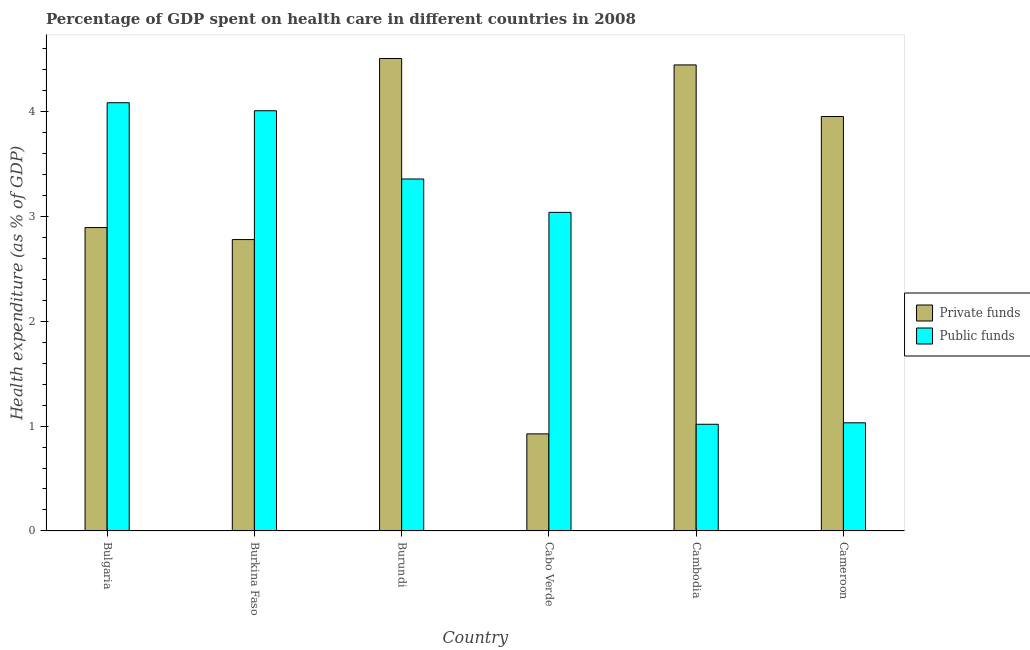Are the number of bars per tick equal to the number of legend labels?
Provide a short and direct response. Yes. How many bars are there on the 5th tick from the right?
Provide a short and direct response. 2. What is the label of the 5th group of bars from the left?
Your answer should be very brief. Cambodia. In how many cases, is the number of bars for a given country not equal to the number of legend labels?
Offer a terse response. 0. What is the amount of private funds spent in healthcare in Bulgaria?
Provide a short and direct response. 2.89. Across all countries, what is the maximum amount of public funds spent in healthcare?
Your answer should be very brief. 4.08. Across all countries, what is the minimum amount of private funds spent in healthcare?
Your answer should be compact. 0.93. In which country was the amount of private funds spent in healthcare minimum?
Your response must be concise. Cabo Verde. What is the total amount of public funds spent in healthcare in the graph?
Your answer should be very brief. 16.53. What is the difference between the amount of public funds spent in healthcare in Cabo Verde and that in Cameroon?
Keep it short and to the point. 2.01. What is the difference between the amount of public funds spent in healthcare in Cambodia and the amount of private funds spent in healthcare in Burkina Faso?
Your response must be concise. -1.76. What is the average amount of private funds spent in healthcare per country?
Offer a terse response. 3.25. What is the difference between the amount of public funds spent in healthcare and amount of private funds spent in healthcare in Cameroon?
Your response must be concise. -2.92. In how many countries, is the amount of private funds spent in healthcare greater than 4.4 %?
Give a very brief answer. 2. What is the ratio of the amount of public funds spent in healthcare in Burundi to that in Cameroon?
Your answer should be compact. 3.25. Is the difference between the amount of private funds spent in healthcare in Cabo Verde and Cameroon greater than the difference between the amount of public funds spent in healthcare in Cabo Verde and Cameroon?
Provide a succinct answer. No. What is the difference between the highest and the second highest amount of public funds spent in healthcare?
Ensure brevity in your answer.  0.08. What is the difference between the highest and the lowest amount of private funds spent in healthcare?
Ensure brevity in your answer.  3.58. In how many countries, is the amount of public funds spent in healthcare greater than the average amount of public funds spent in healthcare taken over all countries?
Your answer should be very brief. 4. What does the 1st bar from the left in Cabo Verde represents?
Keep it short and to the point. Private funds. What does the 2nd bar from the right in Bulgaria represents?
Your answer should be very brief. Private funds. How many bars are there?
Provide a short and direct response. 12. Are all the bars in the graph horizontal?
Offer a terse response. No. How many countries are there in the graph?
Your response must be concise. 6. Are the values on the major ticks of Y-axis written in scientific E-notation?
Your response must be concise. No. Does the graph contain grids?
Offer a terse response. No. How many legend labels are there?
Ensure brevity in your answer.  2. What is the title of the graph?
Offer a very short reply. Percentage of GDP spent on health care in different countries in 2008. Does "Taxes on profits and capital gains" appear as one of the legend labels in the graph?
Your answer should be compact. No. What is the label or title of the Y-axis?
Offer a terse response. Health expenditure (as % of GDP). What is the Health expenditure (as % of GDP) in Private funds in Bulgaria?
Provide a short and direct response. 2.89. What is the Health expenditure (as % of GDP) in Public funds in Bulgaria?
Ensure brevity in your answer.  4.08. What is the Health expenditure (as % of GDP) of Private funds in Burkina Faso?
Provide a short and direct response. 2.78. What is the Health expenditure (as % of GDP) of Public funds in Burkina Faso?
Your response must be concise. 4.01. What is the Health expenditure (as % of GDP) of Private funds in Burundi?
Offer a very short reply. 4.5. What is the Health expenditure (as % of GDP) in Public funds in Burundi?
Your answer should be compact. 3.36. What is the Health expenditure (as % of GDP) in Private funds in Cabo Verde?
Offer a terse response. 0.93. What is the Health expenditure (as % of GDP) of Public funds in Cabo Verde?
Offer a terse response. 3.04. What is the Health expenditure (as % of GDP) of Private funds in Cambodia?
Your response must be concise. 4.44. What is the Health expenditure (as % of GDP) in Public funds in Cambodia?
Your response must be concise. 1.02. What is the Health expenditure (as % of GDP) of Private funds in Cameroon?
Provide a short and direct response. 3.95. What is the Health expenditure (as % of GDP) of Public funds in Cameroon?
Make the answer very short. 1.03. Across all countries, what is the maximum Health expenditure (as % of GDP) of Private funds?
Your answer should be compact. 4.5. Across all countries, what is the maximum Health expenditure (as % of GDP) of Public funds?
Offer a terse response. 4.08. Across all countries, what is the minimum Health expenditure (as % of GDP) of Private funds?
Your answer should be very brief. 0.93. Across all countries, what is the minimum Health expenditure (as % of GDP) in Public funds?
Offer a very short reply. 1.02. What is the total Health expenditure (as % of GDP) of Private funds in the graph?
Make the answer very short. 19.49. What is the total Health expenditure (as % of GDP) of Public funds in the graph?
Your response must be concise. 16.53. What is the difference between the Health expenditure (as % of GDP) of Private funds in Bulgaria and that in Burkina Faso?
Your answer should be compact. 0.11. What is the difference between the Health expenditure (as % of GDP) in Public funds in Bulgaria and that in Burkina Faso?
Offer a very short reply. 0.08. What is the difference between the Health expenditure (as % of GDP) in Private funds in Bulgaria and that in Burundi?
Offer a terse response. -1.61. What is the difference between the Health expenditure (as % of GDP) of Public funds in Bulgaria and that in Burundi?
Your response must be concise. 0.73. What is the difference between the Health expenditure (as % of GDP) in Private funds in Bulgaria and that in Cabo Verde?
Your answer should be very brief. 1.97. What is the difference between the Health expenditure (as % of GDP) in Public funds in Bulgaria and that in Cabo Verde?
Your response must be concise. 1.05. What is the difference between the Health expenditure (as % of GDP) in Private funds in Bulgaria and that in Cambodia?
Make the answer very short. -1.55. What is the difference between the Health expenditure (as % of GDP) in Public funds in Bulgaria and that in Cambodia?
Provide a short and direct response. 3.07. What is the difference between the Health expenditure (as % of GDP) of Private funds in Bulgaria and that in Cameroon?
Make the answer very short. -1.06. What is the difference between the Health expenditure (as % of GDP) of Public funds in Bulgaria and that in Cameroon?
Provide a succinct answer. 3.05. What is the difference between the Health expenditure (as % of GDP) in Private funds in Burkina Faso and that in Burundi?
Provide a succinct answer. -1.73. What is the difference between the Health expenditure (as % of GDP) of Public funds in Burkina Faso and that in Burundi?
Ensure brevity in your answer.  0.65. What is the difference between the Health expenditure (as % of GDP) of Private funds in Burkina Faso and that in Cabo Verde?
Provide a short and direct response. 1.85. What is the difference between the Health expenditure (as % of GDP) in Public funds in Burkina Faso and that in Cabo Verde?
Make the answer very short. 0.97. What is the difference between the Health expenditure (as % of GDP) in Private funds in Burkina Faso and that in Cambodia?
Offer a terse response. -1.67. What is the difference between the Health expenditure (as % of GDP) of Public funds in Burkina Faso and that in Cambodia?
Ensure brevity in your answer.  2.99. What is the difference between the Health expenditure (as % of GDP) in Private funds in Burkina Faso and that in Cameroon?
Offer a terse response. -1.17. What is the difference between the Health expenditure (as % of GDP) of Public funds in Burkina Faso and that in Cameroon?
Your answer should be compact. 2.98. What is the difference between the Health expenditure (as % of GDP) of Private funds in Burundi and that in Cabo Verde?
Your answer should be compact. 3.58. What is the difference between the Health expenditure (as % of GDP) of Public funds in Burundi and that in Cabo Verde?
Keep it short and to the point. 0.32. What is the difference between the Health expenditure (as % of GDP) of Private funds in Burundi and that in Cambodia?
Keep it short and to the point. 0.06. What is the difference between the Health expenditure (as % of GDP) in Public funds in Burundi and that in Cambodia?
Your answer should be compact. 2.34. What is the difference between the Health expenditure (as % of GDP) of Private funds in Burundi and that in Cameroon?
Make the answer very short. 0.55. What is the difference between the Health expenditure (as % of GDP) in Public funds in Burundi and that in Cameroon?
Ensure brevity in your answer.  2.32. What is the difference between the Health expenditure (as % of GDP) in Private funds in Cabo Verde and that in Cambodia?
Ensure brevity in your answer.  -3.52. What is the difference between the Health expenditure (as % of GDP) of Public funds in Cabo Verde and that in Cambodia?
Your answer should be compact. 2.02. What is the difference between the Health expenditure (as % of GDP) of Private funds in Cabo Verde and that in Cameroon?
Your response must be concise. -3.03. What is the difference between the Health expenditure (as % of GDP) in Public funds in Cabo Verde and that in Cameroon?
Offer a terse response. 2.01. What is the difference between the Health expenditure (as % of GDP) in Private funds in Cambodia and that in Cameroon?
Offer a terse response. 0.49. What is the difference between the Health expenditure (as % of GDP) in Public funds in Cambodia and that in Cameroon?
Provide a short and direct response. -0.01. What is the difference between the Health expenditure (as % of GDP) in Private funds in Bulgaria and the Health expenditure (as % of GDP) in Public funds in Burkina Faso?
Keep it short and to the point. -1.11. What is the difference between the Health expenditure (as % of GDP) of Private funds in Bulgaria and the Health expenditure (as % of GDP) of Public funds in Burundi?
Your answer should be compact. -0.46. What is the difference between the Health expenditure (as % of GDP) in Private funds in Bulgaria and the Health expenditure (as % of GDP) in Public funds in Cabo Verde?
Give a very brief answer. -0.15. What is the difference between the Health expenditure (as % of GDP) of Private funds in Bulgaria and the Health expenditure (as % of GDP) of Public funds in Cambodia?
Give a very brief answer. 1.88. What is the difference between the Health expenditure (as % of GDP) of Private funds in Bulgaria and the Health expenditure (as % of GDP) of Public funds in Cameroon?
Offer a terse response. 1.86. What is the difference between the Health expenditure (as % of GDP) of Private funds in Burkina Faso and the Health expenditure (as % of GDP) of Public funds in Burundi?
Provide a succinct answer. -0.58. What is the difference between the Health expenditure (as % of GDP) of Private funds in Burkina Faso and the Health expenditure (as % of GDP) of Public funds in Cabo Verde?
Give a very brief answer. -0.26. What is the difference between the Health expenditure (as % of GDP) in Private funds in Burkina Faso and the Health expenditure (as % of GDP) in Public funds in Cambodia?
Make the answer very short. 1.76. What is the difference between the Health expenditure (as % of GDP) of Private funds in Burkina Faso and the Health expenditure (as % of GDP) of Public funds in Cameroon?
Ensure brevity in your answer.  1.75. What is the difference between the Health expenditure (as % of GDP) in Private funds in Burundi and the Health expenditure (as % of GDP) in Public funds in Cabo Verde?
Give a very brief answer. 1.47. What is the difference between the Health expenditure (as % of GDP) of Private funds in Burundi and the Health expenditure (as % of GDP) of Public funds in Cambodia?
Offer a very short reply. 3.49. What is the difference between the Health expenditure (as % of GDP) of Private funds in Burundi and the Health expenditure (as % of GDP) of Public funds in Cameroon?
Your answer should be compact. 3.47. What is the difference between the Health expenditure (as % of GDP) in Private funds in Cabo Verde and the Health expenditure (as % of GDP) in Public funds in Cambodia?
Ensure brevity in your answer.  -0.09. What is the difference between the Health expenditure (as % of GDP) in Private funds in Cabo Verde and the Health expenditure (as % of GDP) in Public funds in Cameroon?
Provide a succinct answer. -0.11. What is the difference between the Health expenditure (as % of GDP) of Private funds in Cambodia and the Health expenditure (as % of GDP) of Public funds in Cameroon?
Provide a succinct answer. 3.41. What is the average Health expenditure (as % of GDP) in Private funds per country?
Your answer should be compact. 3.25. What is the average Health expenditure (as % of GDP) in Public funds per country?
Offer a very short reply. 2.75. What is the difference between the Health expenditure (as % of GDP) of Private funds and Health expenditure (as % of GDP) of Public funds in Bulgaria?
Your answer should be compact. -1.19. What is the difference between the Health expenditure (as % of GDP) in Private funds and Health expenditure (as % of GDP) in Public funds in Burkina Faso?
Provide a short and direct response. -1.23. What is the difference between the Health expenditure (as % of GDP) in Private funds and Health expenditure (as % of GDP) in Public funds in Burundi?
Make the answer very short. 1.15. What is the difference between the Health expenditure (as % of GDP) in Private funds and Health expenditure (as % of GDP) in Public funds in Cabo Verde?
Make the answer very short. -2.11. What is the difference between the Health expenditure (as % of GDP) in Private funds and Health expenditure (as % of GDP) in Public funds in Cambodia?
Ensure brevity in your answer.  3.43. What is the difference between the Health expenditure (as % of GDP) in Private funds and Health expenditure (as % of GDP) in Public funds in Cameroon?
Your answer should be compact. 2.92. What is the ratio of the Health expenditure (as % of GDP) of Private funds in Bulgaria to that in Burkina Faso?
Provide a succinct answer. 1.04. What is the ratio of the Health expenditure (as % of GDP) in Public funds in Bulgaria to that in Burkina Faso?
Make the answer very short. 1.02. What is the ratio of the Health expenditure (as % of GDP) of Private funds in Bulgaria to that in Burundi?
Provide a short and direct response. 0.64. What is the ratio of the Health expenditure (as % of GDP) of Public funds in Bulgaria to that in Burundi?
Provide a short and direct response. 1.22. What is the ratio of the Health expenditure (as % of GDP) of Private funds in Bulgaria to that in Cabo Verde?
Offer a very short reply. 3.13. What is the ratio of the Health expenditure (as % of GDP) in Public funds in Bulgaria to that in Cabo Verde?
Ensure brevity in your answer.  1.34. What is the ratio of the Health expenditure (as % of GDP) of Private funds in Bulgaria to that in Cambodia?
Your answer should be very brief. 0.65. What is the ratio of the Health expenditure (as % of GDP) in Public funds in Bulgaria to that in Cambodia?
Make the answer very short. 4.01. What is the ratio of the Health expenditure (as % of GDP) in Private funds in Bulgaria to that in Cameroon?
Provide a short and direct response. 0.73. What is the ratio of the Health expenditure (as % of GDP) in Public funds in Bulgaria to that in Cameroon?
Make the answer very short. 3.96. What is the ratio of the Health expenditure (as % of GDP) of Private funds in Burkina Faso to that in Burundi?
Your response must be concise. 0.62. What is the ratio of the Health expenditure (as % of GDP) of Public funds in Burkina Faso to that in Burundi?
Offer a terse response. 1.19. What is the ratio of the Health expenditure (as % of GDP) of Private funds in Burkina Faso to that in Cabo Verde?
Your answer should be compact. 3. What is the ratio of the Health expenditure (as % of GDP) in Public funds in Burkina Faso to that in Cabo Verde?
Provide a succinct answer. 1.32. What is the ratio of the Health expenditure (as % of GDP) of Private funds in Burkina Faso to that in Cambodia?
Offer a terse response. 0.63. What is the ratio of the Health expenditure (as % of GDP) of Public funds in Burkina Faso to that in Cambodia?
Ensure brevity in your answer.  3.94. What is the ratio of the Health expenditure (as % of GDP) in Private funds in Burkina Faso to that in Cameroon?
Provide a succinct answer. 0.7. What is the ratio of the Health expenditure (as % of GDP) in Public funds in Burkina Faso to that in Cameroon?
Offer a terse response. 3.89. What is the ratio of the Health expenditure (as % of GDP) of Private funds in Burundi to that in Cabo Verde?
Your answer should be very brief. 4.87. What is the ratio of the Health expenditure (as % of GDP) in Public funds in Burundi to that in Cabo Verde?
Your answer should be compact. 1.1. What is the ratio of the Health expenditure (as % of GDP) of Private funds in Burundi to that in Cambodia?
Offer a terse response. 1.01. What is the ratio of the Health expenditure (as % of GDP) of Public funds in Burundi to that in Cambodia?
Give a very brief answer. 3.3. What is the ratio of the Health expenditure (as % of GDP) in Private funds in Burundi to that in Cameroon?
Provide a succinct answer. 1.14. What is the ratio of the Health expenditure (as % of GDP) in Public funds in Burundi to that in Cameroon?
Make the answer very short. 3.25. What is the ratio of the Health expenditure (as % of GDP) of Private funds in Cabo Verde to that in Cambodia?
Make the answer very short. 0.21. What is the ratio of the Health expenditure (as % of GDP) in Public funds in Cabo Verde to that in Cambodia?
Your answer should be compact. 2.99. What is the ratio of the Health expenditure (as % of GDP) in Private funds in Cabo Verde to that in Cameroon?
Offer a terse response. 0.23. What is the ratio of the Health expenditure (as % of GDP) of Public funds in Cabo Verde to that in Cameroon?
Make the answer very short. 2.95. What is the ratio of the Health expenditure (as % of GDP) in Private funds in Cambodia to that in Cameroon?
Provide a short and direct response. 1.12. What is the ratio of the Health expenditure (as % of GDP) in Public funds in Cambodia to that in Cameroon?
Keep it short and to the point. 0.99. What is the difference between the highest and the second highest Health expenditure (as % of GDP) in Private funds?
Offer a terse response. 0.06. What is the difference between the highest and the second highest Health expenditure (as % of GDP) of Public funds?
Keep it short and to the point. 0.08. What is the difference between the highest and the lowest Health expenditure (as % of GDP) of Private funds?
Make the answer very short. 3.58. What is the difference between the highest and the lowest Health expenditure (as % of GDP) in Public funds?
Your response must be concise. 3.07. 